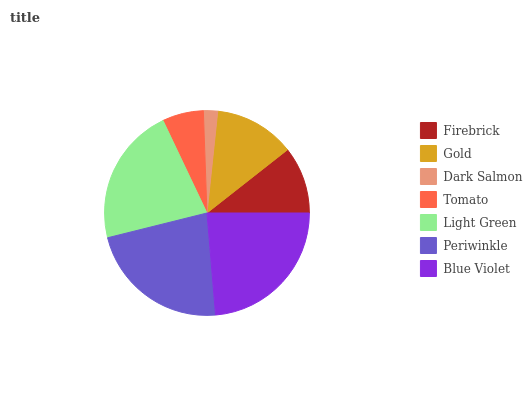Is Dark Salmon the minimum?
Answer yes or no. Yes. Is Blue Violet the maximum?
Answer yes or no. Yes. Is Gold the minimum?
Answer yes or no. No. Is Gold the maximum?
Answer yes or no. No. Is Gold greater than Firebrick?
Answer yes or no. Yes. Is Firebrick less than Gold?
Answer yes or no. Yes. Is Firebrick greater than Gold?
Answer yes or no. No. Is Gold less than Firebrick?
Answer yes or no. No. Is Gold the high median?
Answer yes or no. Yes. Is Gold the low median?
Answer yes or no. Yes. Is Tomato the high median?
Answer yes or no. No. Is Light Green the low median?
Answer yes or no. No. 